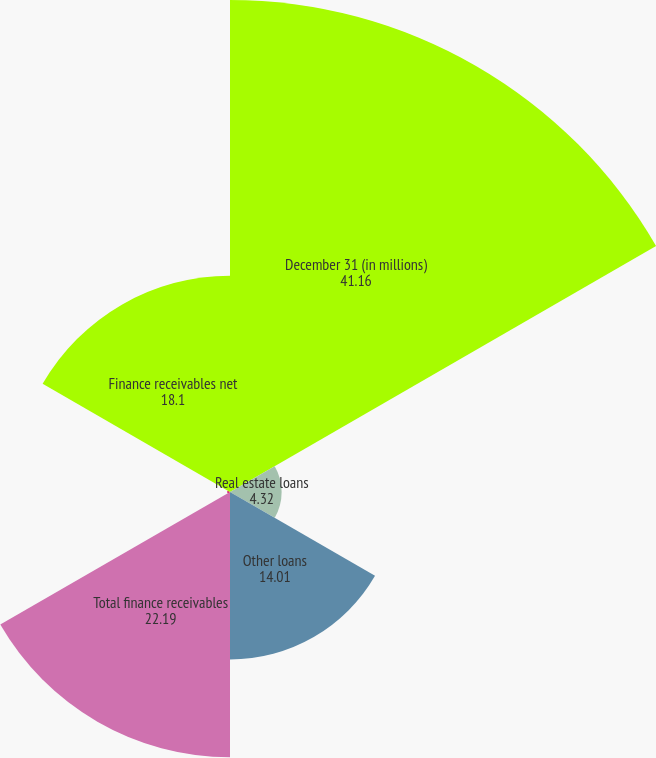Convert chart. <chart><loc_0><loc_0><loc_500><loc_500><pie_chart><fcel>December 31 (in millions)<fcel>Real estate loans<fcel>Other loans<fcel>Total finance receivables<fcel>Allowance for losses<fcel>Finance receivables net<nl><fcel>41.16%<fcel>4.32%<fcel>14.01%<fcel>22.19%<fcel>0.23%<fcel>18.1%<nl></chart> 